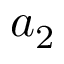Convert formula to latex. <formula><loc_0><loc_0><loc_500><loc_500>a _ { 2 }</formula> 